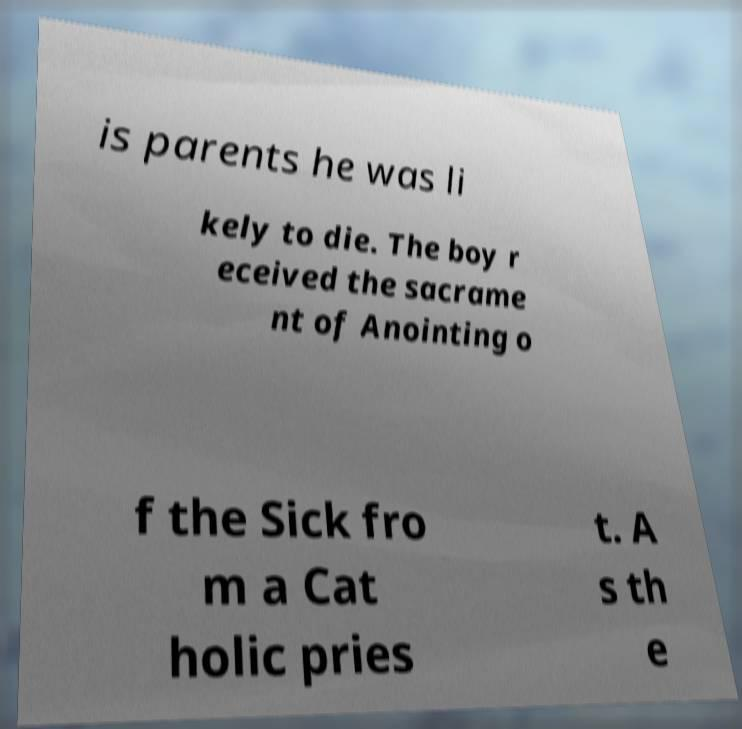Can you read and provide the text displayed in the image?This photo seems to have some interesting text. Can you extract and type it out for me? is parents he was li kely to die. The boy r eceived the sacrame nt of Anointing o f the Sick fro m a Cat holic pries t. A s th e 